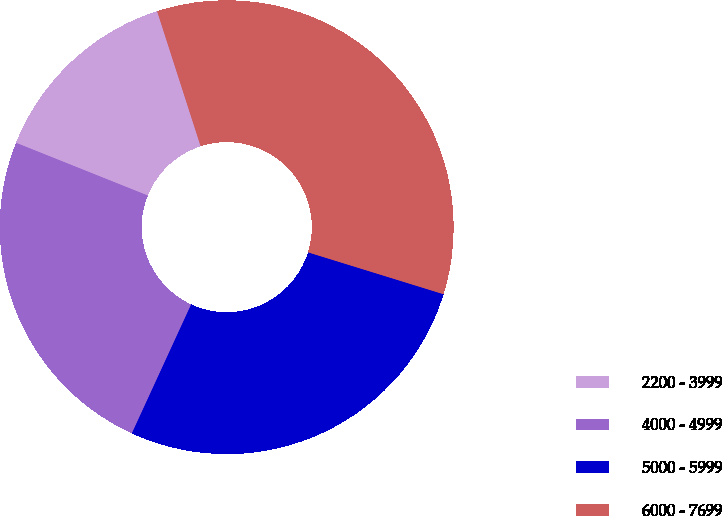Convert chart to OTSL. <chart><loc_0><loc_0><loc_500><loc_500><pie_chart><fcel>2200 - 3999<fcel>4000 - 4999<fcel>5000 - 5999<fcel>6000 - 7699<nl><fcel>13.98%<fcel>24.2%<fcel>27.09%<fcel>34.73%<nl></chart> 